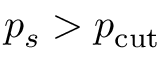<formula> <loc_0><loc_0><loc_500><loc_500>p _ { s } > p _ { c u t }</formula> 